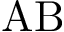Convert formula to latex. <formula><loc_0><loc_0><loc_500><loc_500>A B</formula> 